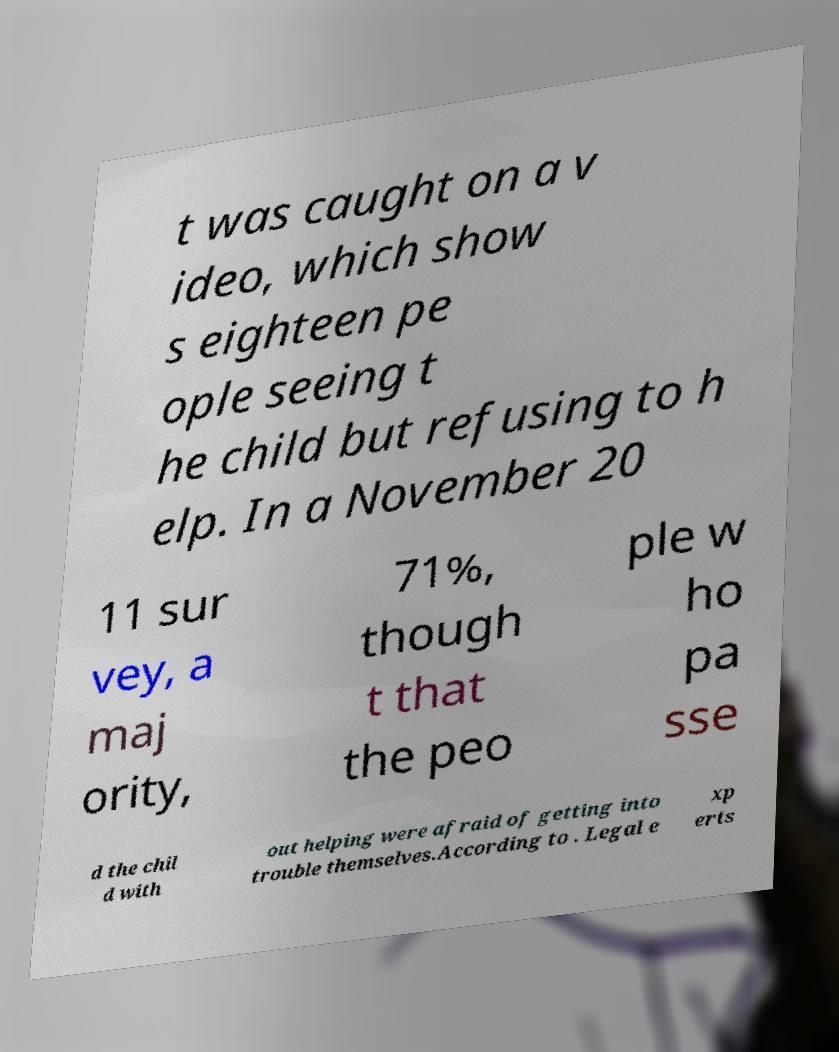Can you accurately transcribe the text from the provided image for me? t was caught on a v ideo, which show s eighteen pe ople seeing t he child but refusing to h elp. In a November 20 11 sur vey, a maj ority, 71%, though t that the peo ple w ho pa sse d the chil d with out helping were afraid of getting into trouble themselves.According to . Legal e xp erts 